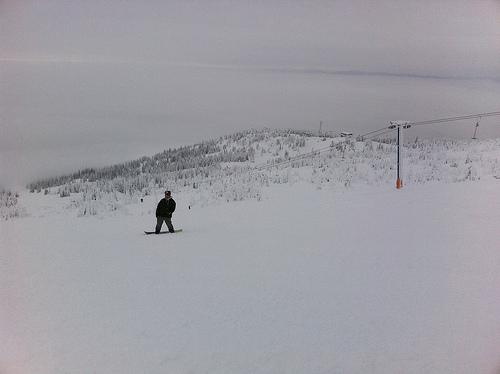Analyze object interactions in the image related to the person involved in a sport. The snowboarder balances with legs apart while navigating the snow-covered slope. How would you rate the image for its content and potential to elicit emotions? The image has an exciting and adventurous content, which can evoke excitement and admiration. Provide a description of the scenery in the image. The scenery features a snow-covered slope with a snowboarder, trees, a tower in the distance, and a small structure. Are there any landmarks or structures visible in the image? Briefly mention them. Yes, there is a tower and a small structure in the distance. What object in the image is the farthest to the right? The tower in the distance is the farthest object to the right. Discuss the position of the snowboarder's limbs. The snowboarder has their legs apart on the board and arms close to their body. Can you count the number of snow-covered areas in the image? There are 13 snow-covered areas in the image. Briefly describe the image's noticeable boundaries and landmarks. A curved snow-covered slope, upright tree stubble, pole and wires, tower, a small structure, and the snowboarder are noticeable boundaries and landmarks. What is the primary sport-related activity occurring in the image? Snowboarding is the primary sport-related activity in the image. Can you see the sun setting behind the mountains in the background? No, it's not mentioned in the image. Are there three small trees on the left side of the slope creating a diagonal line? While there is mention of trees in the image, there is no information about the number or specific arrangement of the trees. We cannot determine if there are three trees forming a diagonal line. Is the person in the snow wearing a bright red jacket? There is no information about the color of the person's clothing in the image, so we cannot answer this question accurately. 